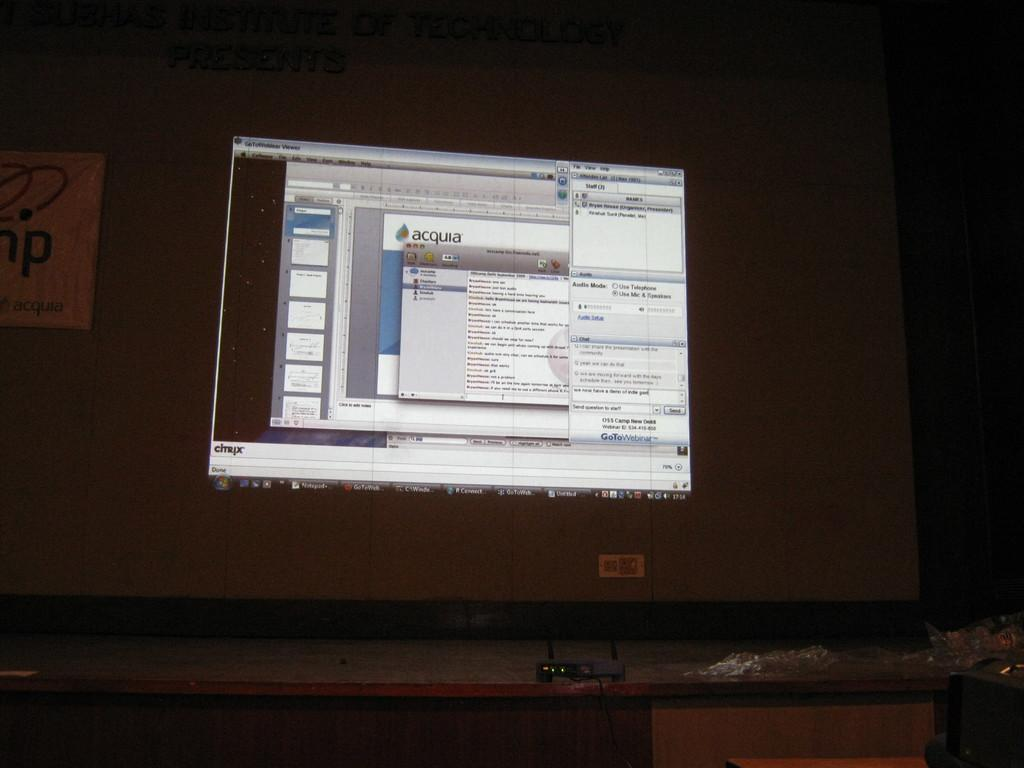What is the main object in the center of the image? There is a screen in the center of the image. What device is used to project onto the screen? There is a projector placed on a table in the image. What type of seed is being planted by the children in the image? There are no children or seeds present in the image; it only features a screen and a projector. 